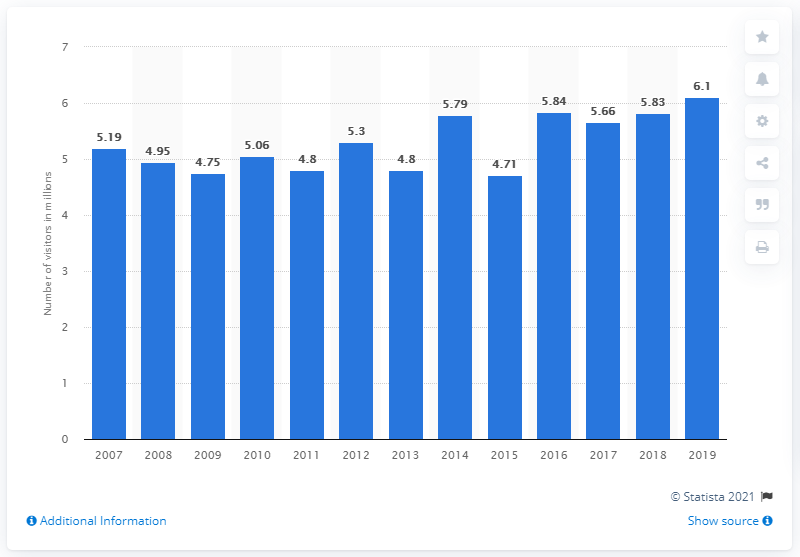Identify some key points in this picture. In the year 2019, the Tate Modern art museum in London was visited by 6.1 million people. 